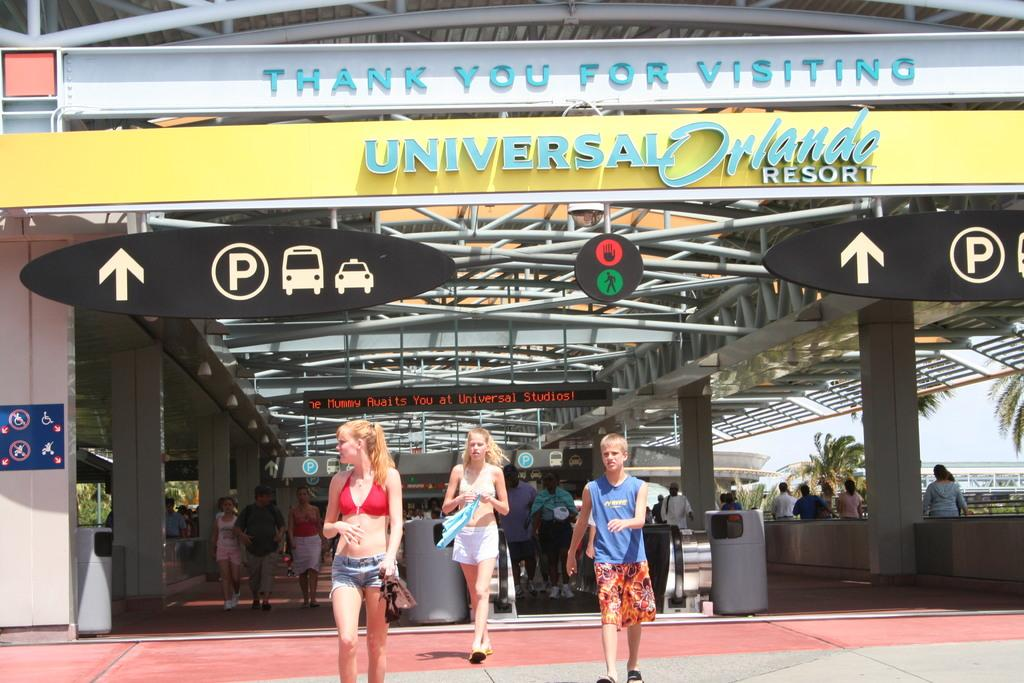What are the people in the image doing? The people in the image are walking on the floor. What can be used for navigation in the image? Direction boards and name boards are present in the image for navigation. What architectural features can be seen in the image? Pillars are present in the image. What other objects can be seen in the image? Rods are visible in the image, along with other objects. What can be seen in the background of the image? Trees and the sky are visible in the background of the image. Can you tell me how many robins are perched on the rods in the image? There are no robins present in the image; it only features people walking, direction boards, name boards, pillars, rods, and objects. What type of stage can be seen in the image? There is no stage present in the image. 